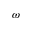Convert formula to latex. <formula><loc_0><loc_0><loc_500><loc_500>\omega</formula> 